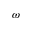Convert formula to latex. <formula><loc_0><loc_0><loc_500><loc_500>\omega</formula> 